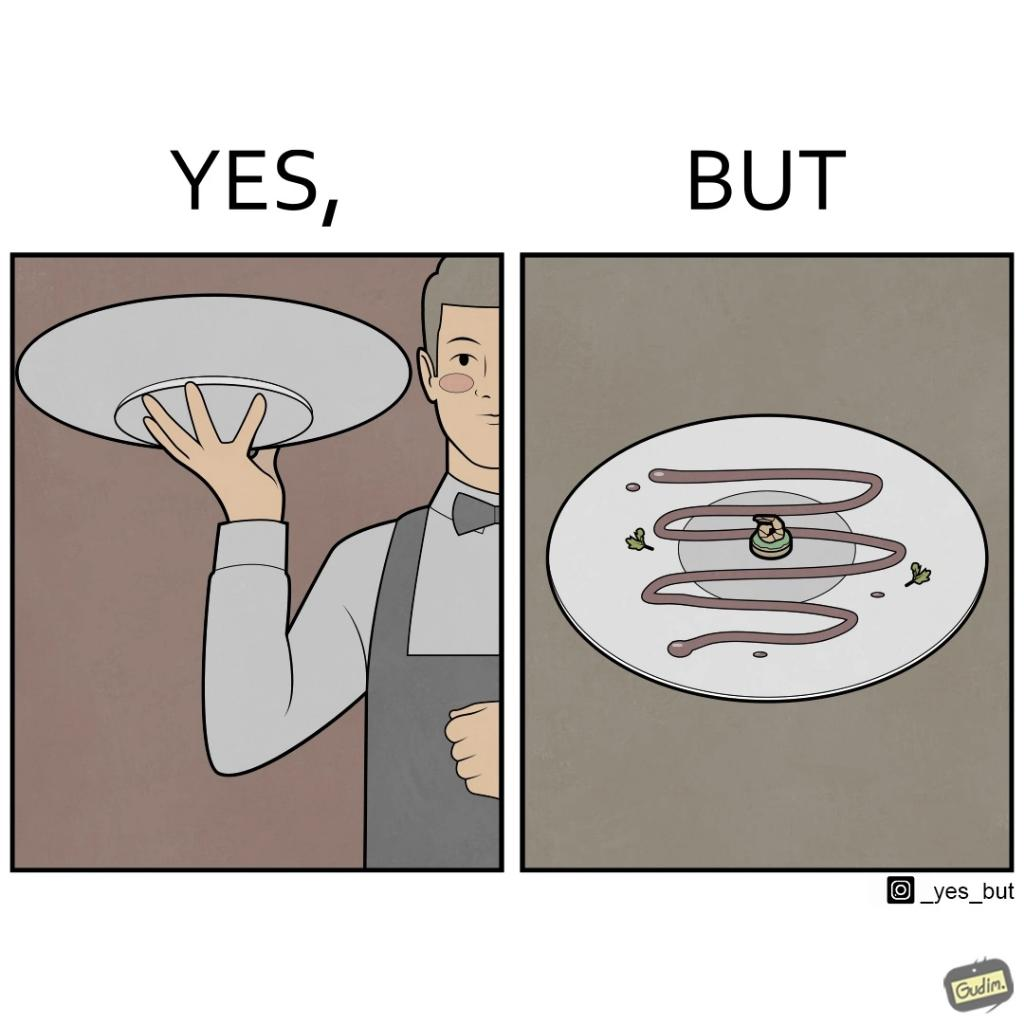Does this image contain satire or humor? Yes, this image is satirical. 